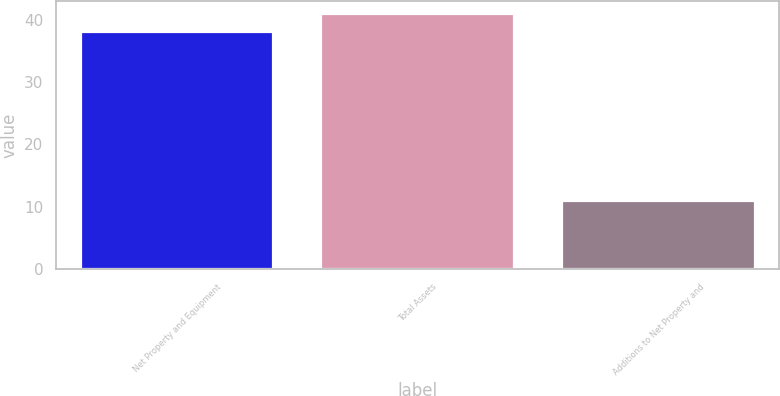Convert chart to OTSL. <chart><loc_0><loc_0><loc_500><loc_500><bar_chart><fcel>Net Property and Equipment<fcel>Total Assets<fcel>Additions to Net Property and<nl><fcel>38<fcel>40.9<fcel>11<nl></chart> 